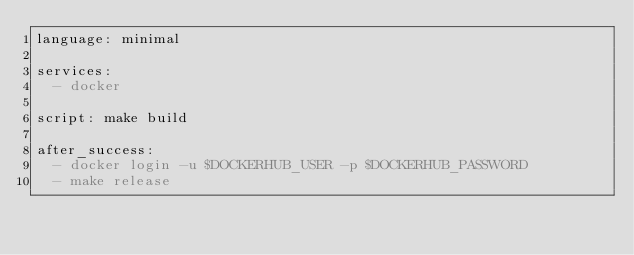<code> <loc_0><loc_0><loc_500><loc_500><_YAML_>language: minimal

services:
  - docker

script: make build

after_success:
  - docker login -u $DOCKERHUB_USER -p $DOCKERHUB_PASSWORD
  - make release
</code> 